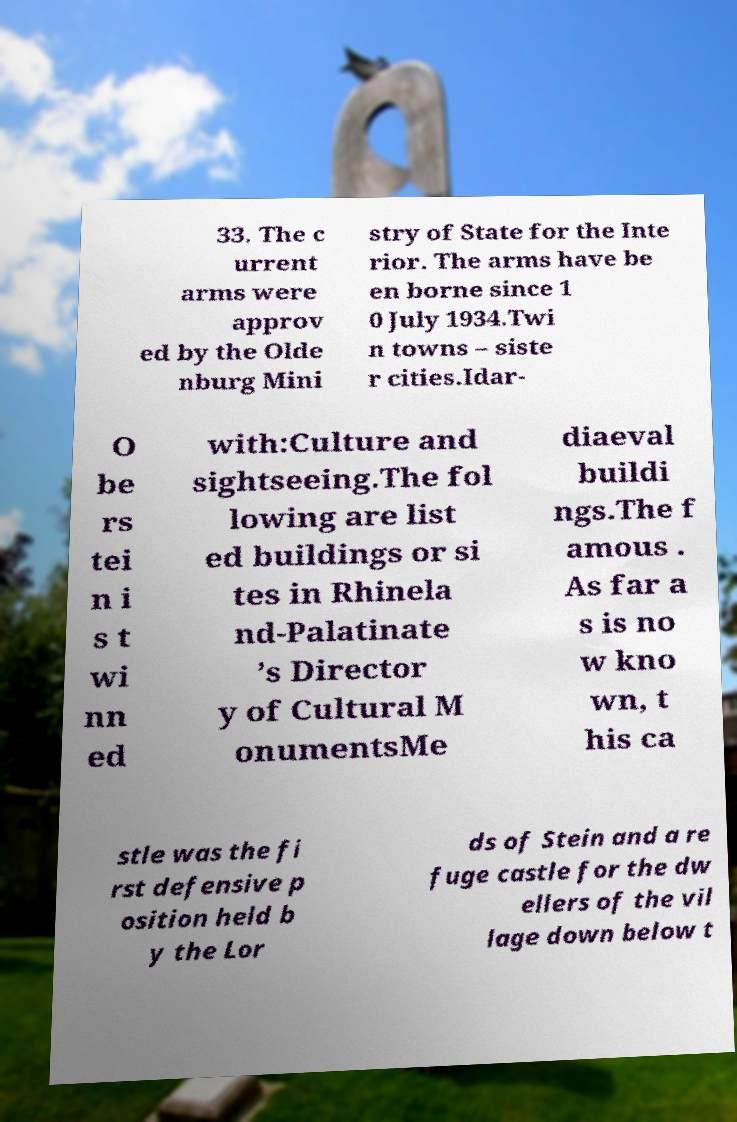Can you accurately transcribe the text from the provided image for me? 33. The c urrent arms were approv ed by the Olde nburg Mini stry of State for the Inte rior. The arms have be en borne since 1 0 July 1934.Twi n towns – siste r cities.Idar- O be rs tei n i s t wi nn ed with:Culture and sightseeing.The fol lowing are list ed buildings or si tes in Rhinela nd-Palatinate ’s Director y of Cultural M onumentsMe diaeval buildi ngs.The f amous . As far a s is no w kno wn, t his ca stle was the fi rst defensive p osition held b y the Lor ds of Stein and a re fuge castle for the dw ellers of the vil lage down below t 